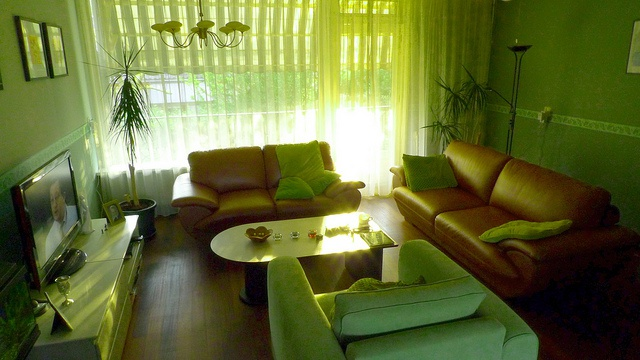Describe the objects in this image and their specific colors. I can see couch in olive, black, and maroon tones, couch in olive, darkgreen, green, and black tones, chair in olive, darkgreen, green, and black tones, couch in olive, black, and darkgreen tones, and tv in olive, black, darkgreen, and gray tones in this image. 